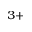Convert formula to latex. <formula><loc_0><loc_0><loc_500><loc_500>^ { 3 + }</formula> 